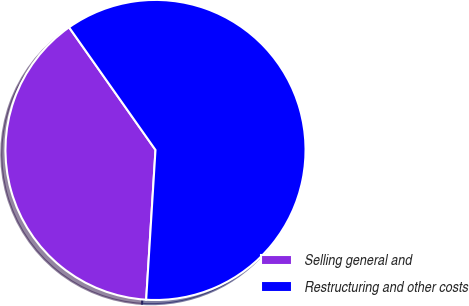Convert chart. <chart><loc_0><loc_0><loc_500><loc_500><pie_chart><fcel>Selling general and<fcel>Restructuring and other costs<nl><fcel>39.24%<fcel>60.76%<nl></chart> 